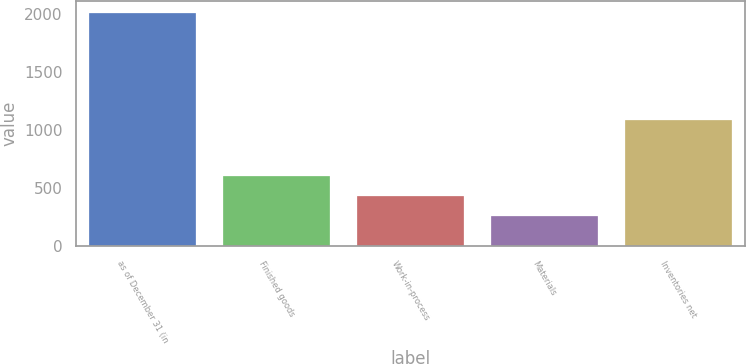Convert chart to OTSL. <chart><loc_0><loc_0><loc_500><loc_500><bar_chart><fcel>as of December 31 (in<fcel>Finished goods<fcel>Work-in-process<fcel>Materials<fcel>Inventories net<nl><fcel>2012<fcel>608.8<fcel>433.4<fcel>258<fcel>1091<nl></chart> 